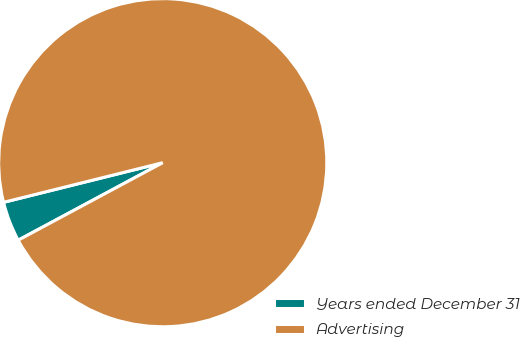Convert chart to OTSL. <chart><loc_0><loc_0><loc_500><loc_500><pie_chart><fcel>Years ended December 31<fcel>Advertising<nl><fcel>3.95%<fcel>96.05%<nl></chart> 